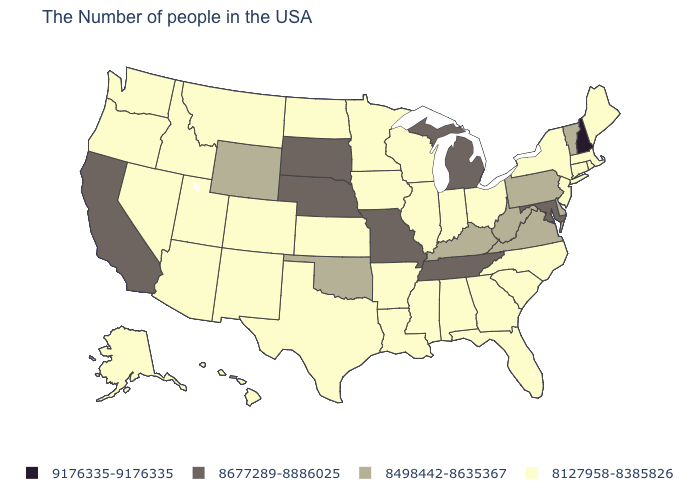Does the map have missing data?
Concise answer only. No. Among the states that border Arkansas , does Tennessee have the highest value?
Quick response, please. Yes. Name the states that have a value in the range 8498442-8635367?
Be succinct. Vermont, Delaware, Pennsylvania, Virginia, West Virginia, Kentucky, Oklahoma, Wyoming. What is the value of Delaware?
Give a very brief answer. 8498442-8635367. What is the highest value in states that border West Virginia?
Give a very brief answer. 8677289-8886025. What is the value of Idaho?
Keep it brief. 8127958-8385826. What is the highest value in states that border New York?
Answer briefly. 8498442-8635367. Name the states that have a value in the range 8677289-8886025?
Be succinct. Maryland, Michigan, Tennessee, Missouri, Nebraska, South Dakota, California. Name the states that have a value in the range 8677289-8886025?
Short answer required. Maryland, Michigan, Tennessee, Missouri, Nebraska, South Dakota, California. Which states have the lowest value in the USA?
Short answer required. Maine, Massachusetts, Rhode Island, Connecticut, New York, New Jersey, North Carolina, South Carolina, Ohio, Florida, Georgia, Indiana, Alabama, Wisconsin, Illinois, Mississippi, Louisiana, Arkansas, Minnesota, Iowa, Kansas, Texas, North Dakota, Colorado, New Mexico, Utah, Montana, Arizona, Idaho, Nevada, Washington, Oregon, Alaska, Hawaii. Which states have the highest value in the USA?
Be succinct. New Hampshire. Name the states that have a value in the range 8127958-8385826?
Answer briefly. Maine, Massachusetts, Rhode Island, Connecticut, New York, New Jersey, North Carolina, South Carolina, Ohio, Florida, Georgia, Indiana, Alabama, Wisconsin, Illinois, Mississippi, Louisiana, Arkansas, Minnesota, Iowa, Kansas, Texas, North Dakota, Colorado, New Mexico, Utah, Montana, Arizona, Idaho, Nevada, Washington, Oregon, Alaska, Hawaii. What is the value of Montana?
Be succinct. 8127958-8385826. What is the highest value in the Northeast ?
Short answer required. 9176335-9176335. Name the states that have a value in the range 8677289-8886025?
Short answer required. Maryland, Michigan, Tennessee, Missouri, Nebraska, South Dakota, California. 